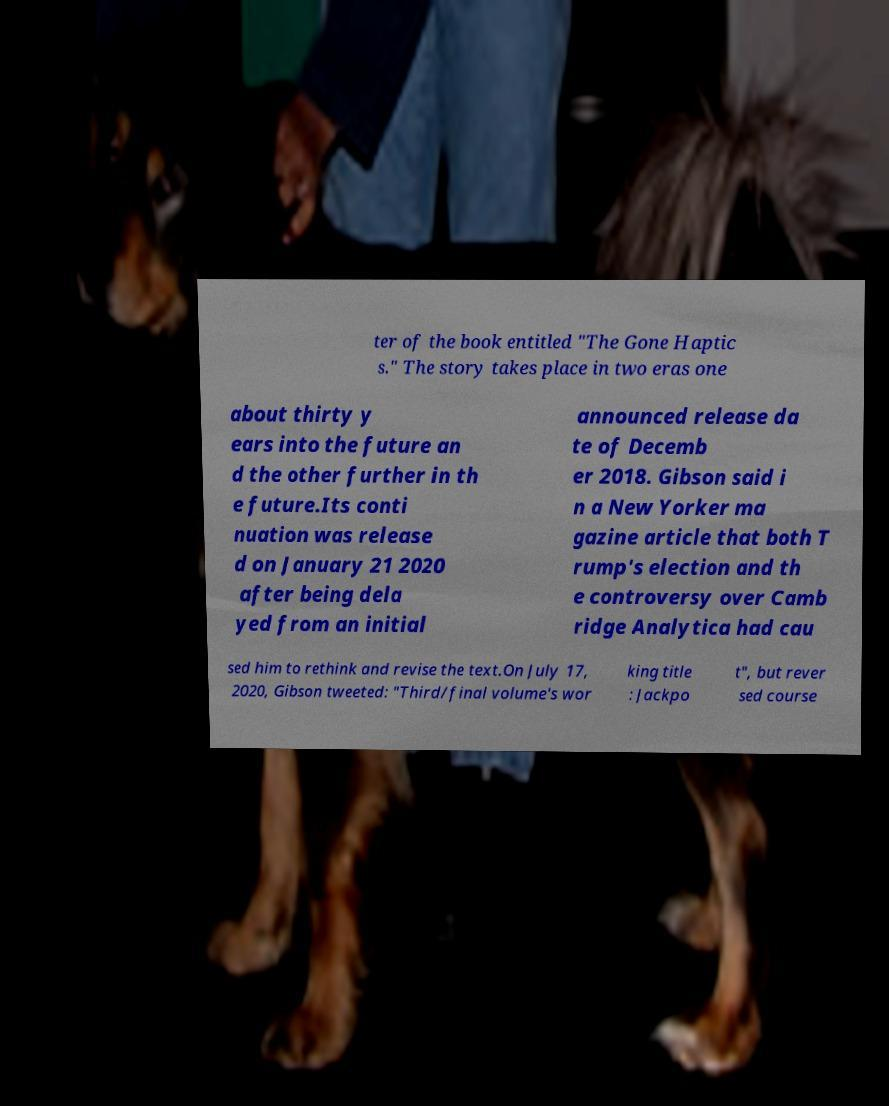There's text embedded in this image that I need extracted. Can you transcribe it verbatim? ter of the book entitled "The Gone Haptic s." The story takes place in two eras one about thirty y ears into the future an d the other further in th e future.Its conti nuation was release d on January 21 2020 after being dela yed from an initial announced release da te of Decemb er 2018. Gibson said i n a New Yorker ma gazine article that both T rump's election and th e controversy over Camb ridge Analytica had cau sed him to rethink and revise the text.On July 17, 2020, Gibson tweeted: "Third/final volume's wor king title : Jackpo t", but rever sed course 